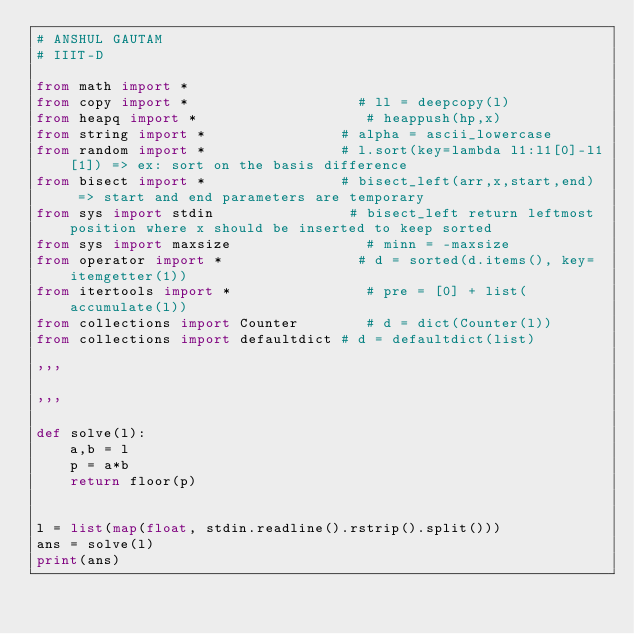<code> <loc_0><loc_0><loc_500><loc_500><_Python_># ANSHUL GAUTAM
# IIIT-D

from math import *
from copy import *                    # ll = deepcopy(l)
from heapq import *                    # heappush(hp,x)
from string import *                # alpha = ascii_lowercase
from random import *                # l.sort(key=lambda l1:l1[0]-l1[1]) => ex: sort on the basis difference
from bisect import *                # bisect_left(arr,x,start,end)  => start and end parameters are temporary
from sys import stdin                # bisect_left return leftmost position where x should be inserted to keep sorted
from sys import maxsize                # minn = -maxsize
from operator import *                # d = sorted(d.items(), key=itemgetter(1))
from itertools import *                # pre = [0] + list(accumulate(l))
from collections import Counter        # d = dict(Counter(l))
from collections import defaultdict # d = defaultdict(list)

'''

'''

def solve(l):
	a,b = l
	p = a*b
	return floor(p)
	

l = list(map(float, stdin.readline().rstrip().split()))
ans = solve(l)
print(ans)

</code> 